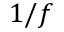<formula> <loc_0><loc_0><loc_500><loc_500>1 / f</formula> 